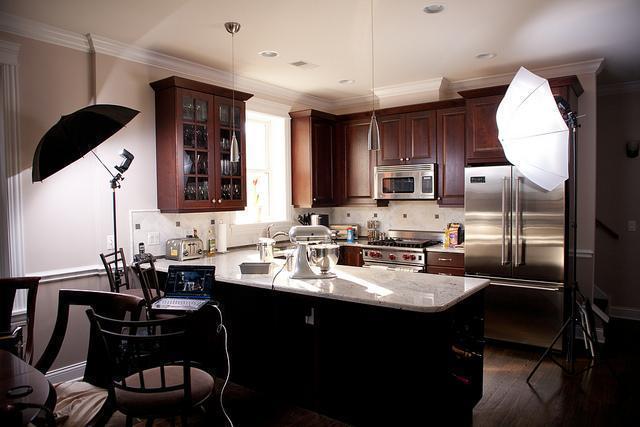What are the umbrellas being used for?
Make your selection and explain in format: 'Answer: answer
Rationale: rationale.'
Options: Lighting, blocking sun, stopping rain, decoration. Answer: lighting.
Rationale: With recording videos you must dim the lights so it won't be so bright. 